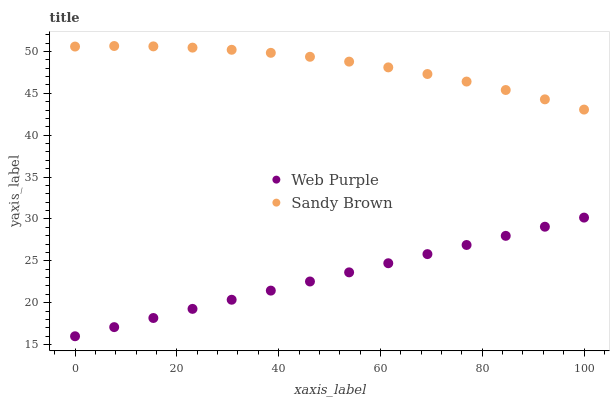Does Web Purple have the minimum area under the curve?
Answer yes or no. Yes. Does Sandy Brown have the maximum area under the curve?
Answer yes or no. Yes. Does Sandy Brown have the minimum area under the curve?
Answer yes or no. No. Is Web Purple the smoothest?
Answer yes or no. Yes. Is Sandy Brown the roughest?
Answer yes or no. Yes. Is Sandy Brown the smoothest?
Answer yes or no. No. Does Web Purple have the lowest value?
Answer yes or no. Yes. Does Sandy Brown have the lowest value?
Answer yes or no. No. Does Sandy Brown have the highest value?
Answer yes or no. Yes. Is Web Purple less than Sandy Brown?
Answer yes or no. Yes. Is Sandy Brown greater than Web Purple?
Answer yes or no. Yes. Does Web Purple intersect Sandy Brown?
Answer yes or no. No. 